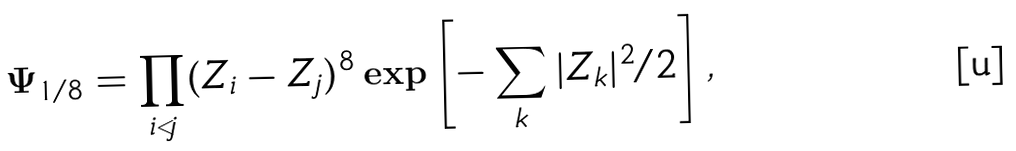Convert formula to latex. <formula><loc_0><loc_0><loc_500><loc_500>\Psi _ { 1 / 8 } = \prod _ { i < j } ( Z _ { i } - Z _ { j } ) ^ { 8 } \exp \left [ - \sum _ { k } | Z _ { k } | ^ { 2 } / 2 \right ] ,</formula> 